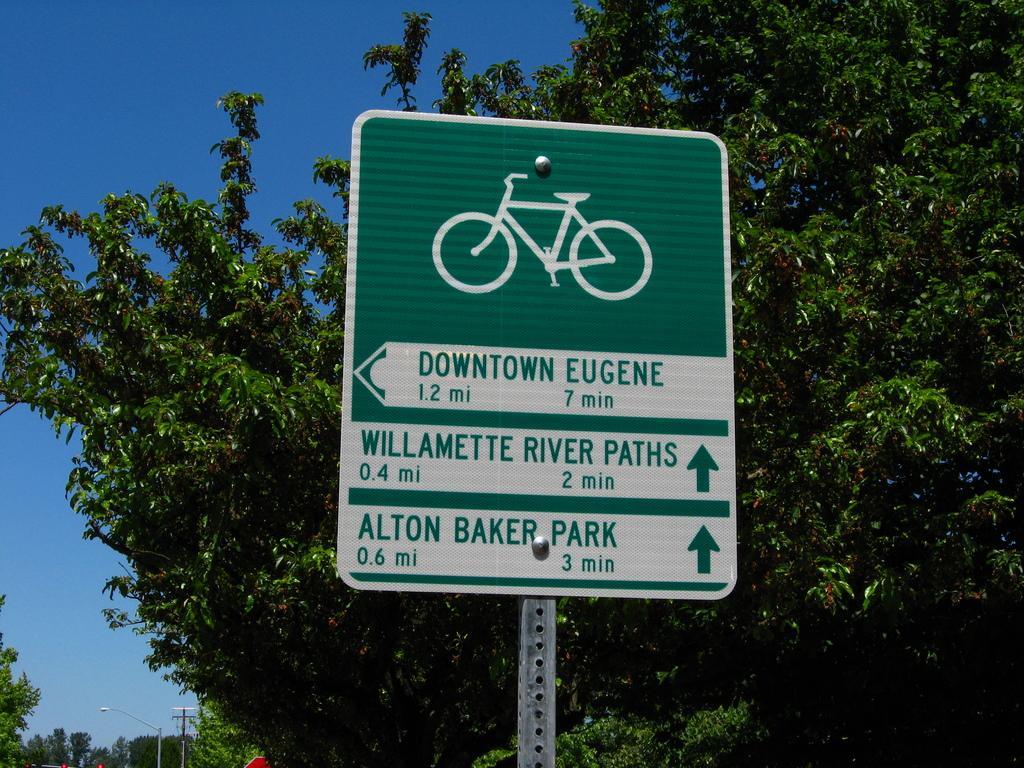Can you describe this image briefly? In the image there is a caution board in the middle with plants behind it and above its sky. 